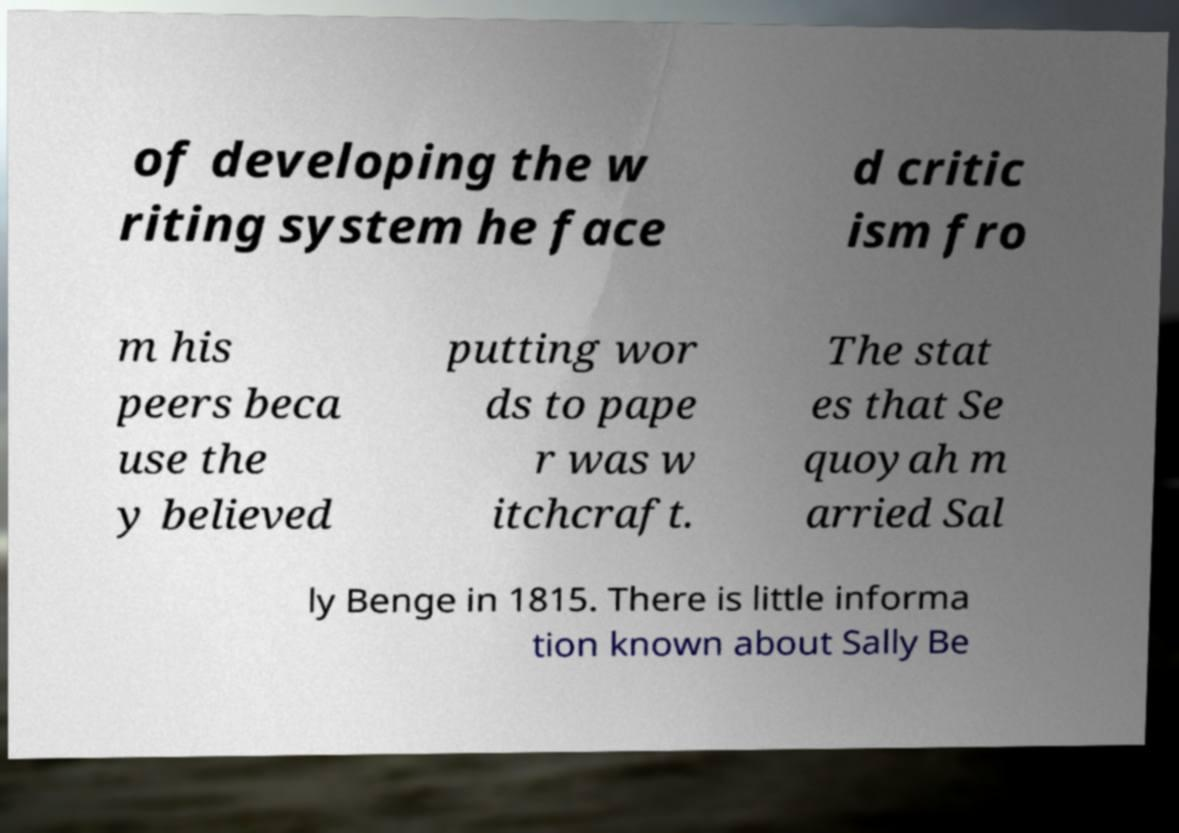I need the written content from this picture converted into text. Can you do that? of developing the w riting system he face d critic ism fro m his peers beca use the y believed putting wor ds to pape r was w itchcraft. The stat es that Se quoyah m arried Sal ly Benge in 1815. There is little informa tion known about Sally Be 